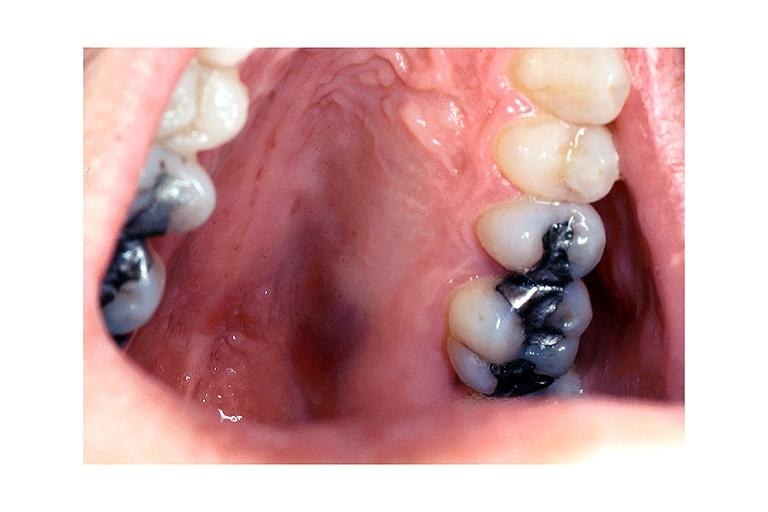does single metastatic appearing lesion show kaposi sarcoma?
Answer the question using a single word or phrase. No 